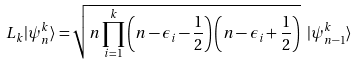<formula> <loc_0><loc_0><loc_500><loc_500>L _ { k } | \psi _ { n } ^ { k } \rangle = \sqrt { n \prod _ { i = 1 } ^ { k } \left ( n - \epsilon _ { i } - \frac { 1 } { 2 } \right ) \left ( n - \epsilon _ { i } + \frac { 1 } { 2 } \right ) } \ | \psi _ { n - 1 } ^ { k } \rangle</formula> 